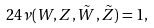Convert formula to latex. <formula><loc_0><loc_0><loc_500><loc_500>2 4 \nu ( W , Z , \tilde { W } , \tilde { Z } ) = 1 ,</formula> 